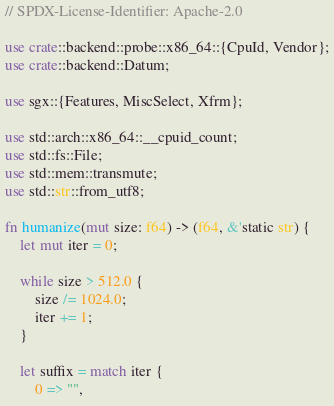<code> <loc_0><loc_0><loc_500><loc_500><_Rust_>// SPDX-License-Identifier: Apache-2.0

use crate::backend::probe::x86_64::{CpuId, Vendor};
use crate::backend::Datum;

use sgx::{Features, MiscSelect, Xfrm};

use std::arch::x86_64::__cpuid_count;
use std::fs::File;
use std::mem::transmute;
use std::str::from_utf8;

fn humanize(mut size: f64) -> (f64, &'static str) {
    let mut iter = 0;

    while size > 512.0 {
        size /= 1024.0;
        iter += 1;
    }

    let suffix = match iter {
        0 => "",</code> 